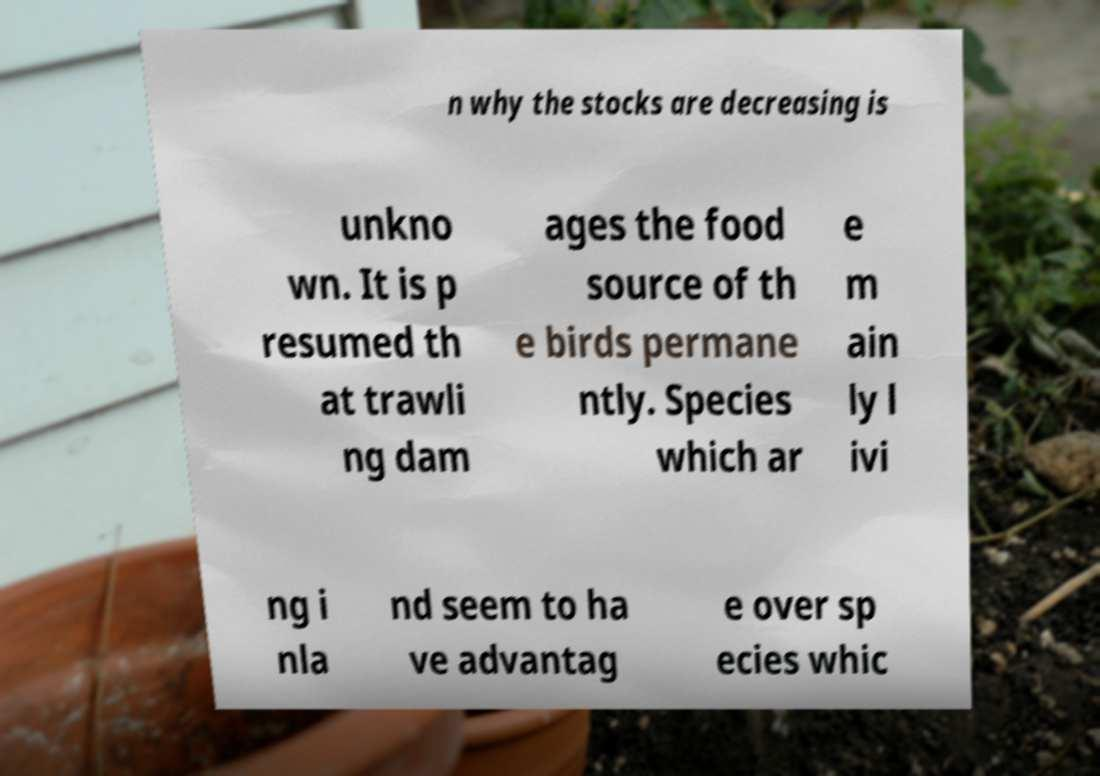Please read and relay the text visible in this image. What does it say? n why the stocks are decreasing is unkno wn. It is p resumed th at trawli ng dam ages the food source of th e birds permane ntly. Species which ar e m ain ly l ivi ng i nla nd seem to ha ve advantag e over sp ecies whic 